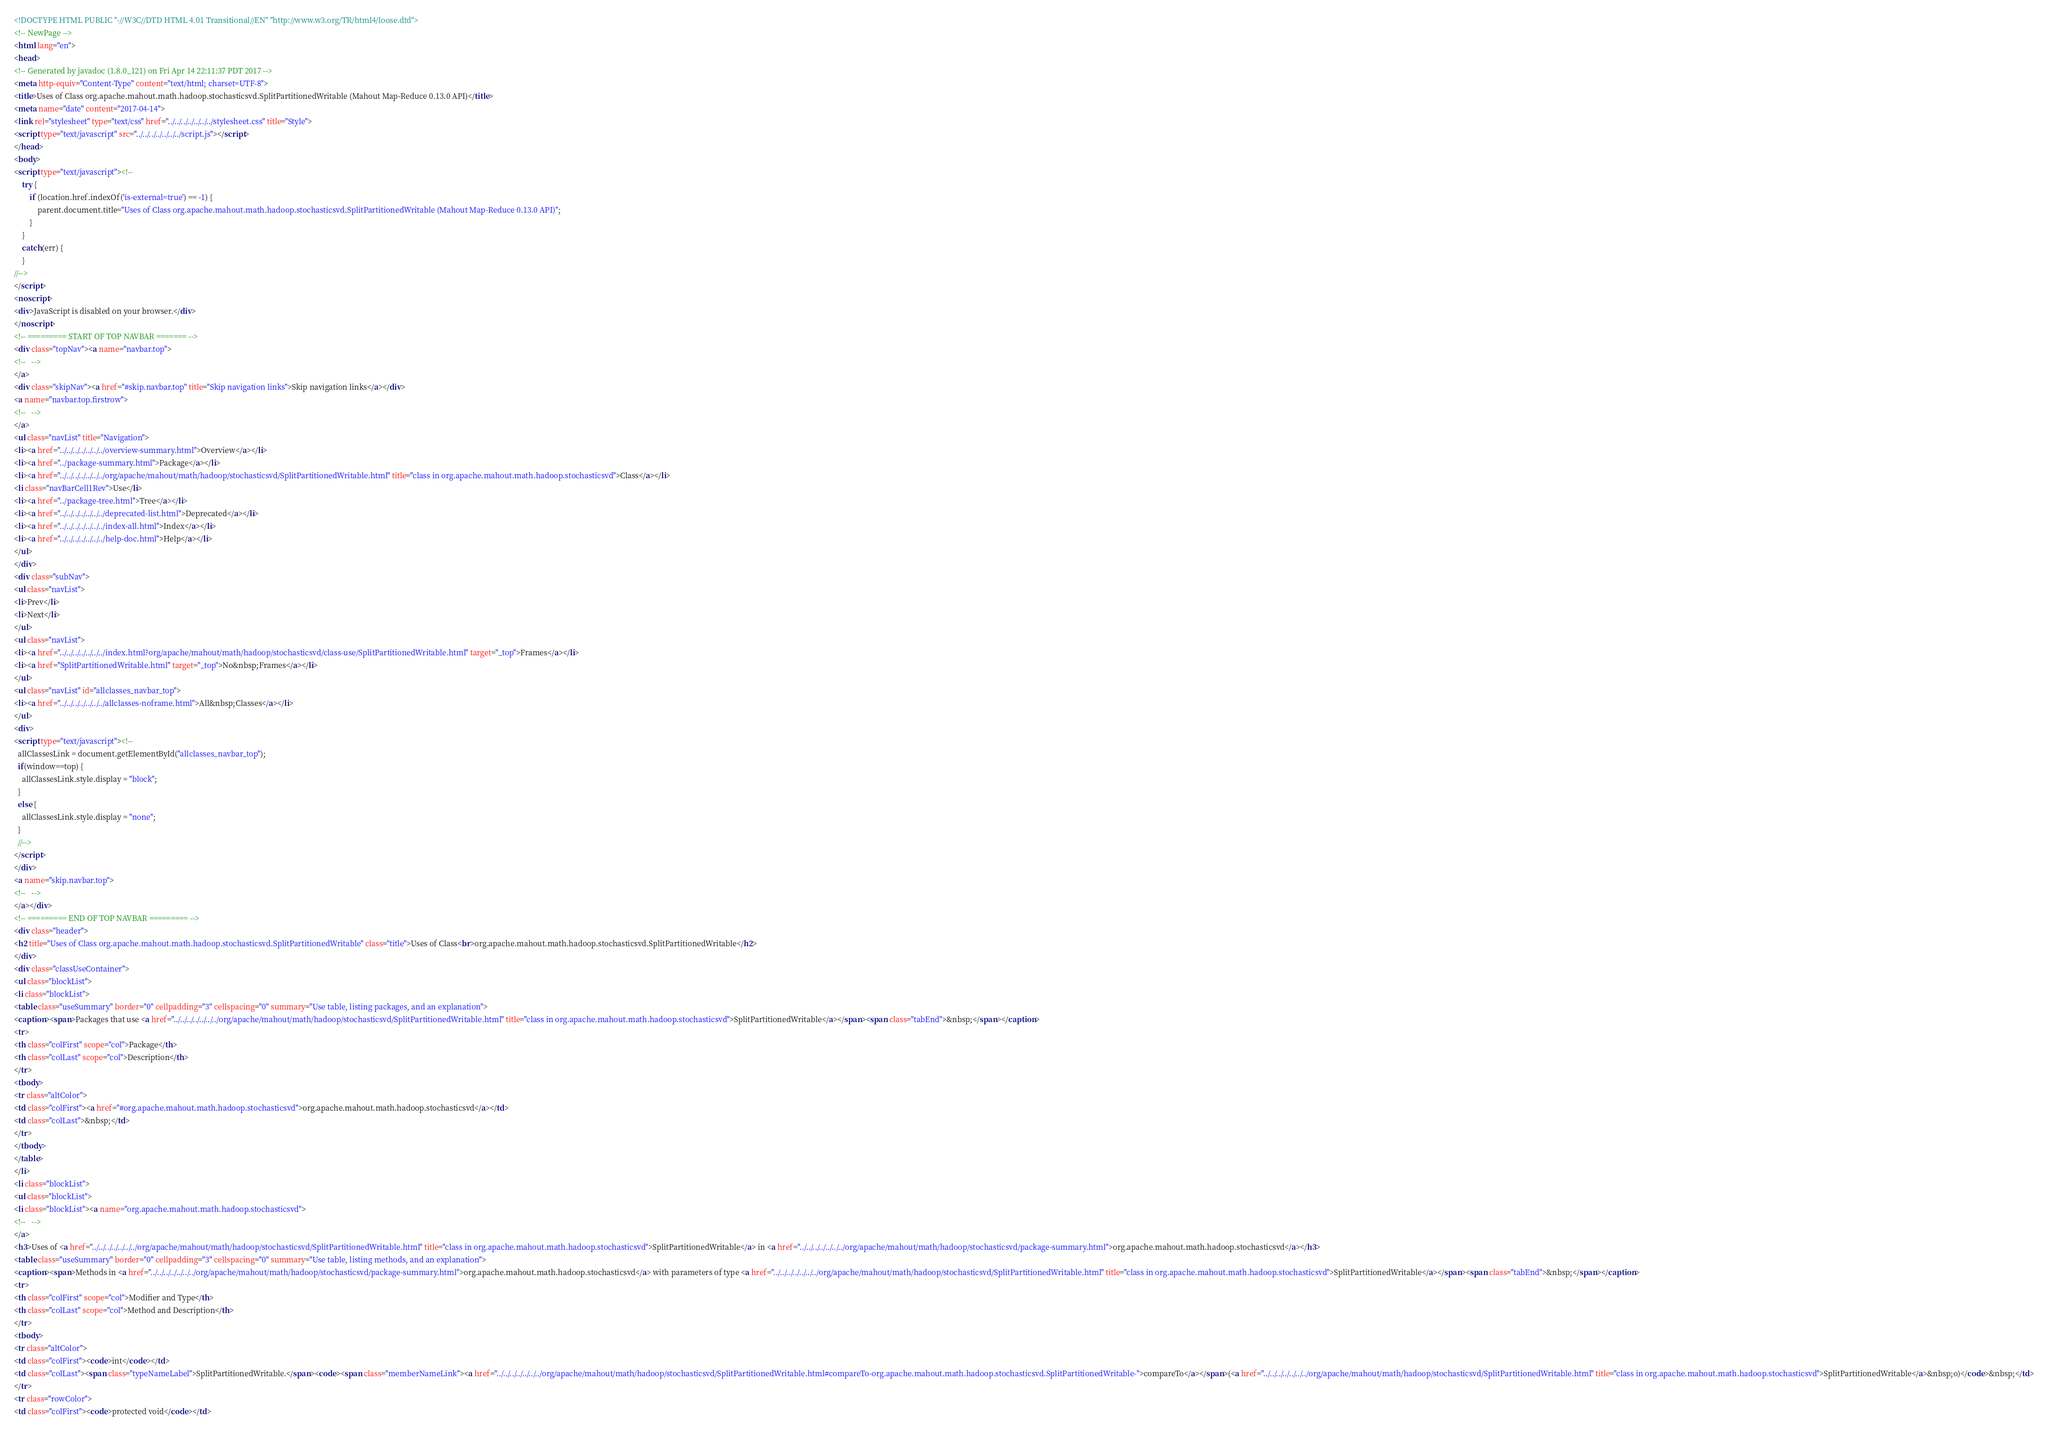<code> <loc_0><loc_0><loc_500><loc_500><_HTML_><!DOCTYPE HTML PUBLIC "-//W3C//DTD HTML 4.01 Transitional//EN" "http://www.w3.org/TR/html4/loose.dtd">
<!-- NewPage -->
<html lang="en">
<head>
<!-- Generated by javadoc (1.8.0_121) on Fri Apr 14 22:11:37 PDT 2017 -->
<meta http-equiv="Content-Type" content="text/html; charset=UTF-8">
<title>Uses of Class org.apache.mahout.math.hadoop.stochasticsvd.SplitPartitionedWritable (Mahout Map-Reduce 0.13.0 API)</title>
<meta name="date" content="2017-04-14">
<link rel="stylesheet" type="text/css" href="../../../../../../../stylesheet.css" title="Style">
<script type="text/javascript" src="../../../../../../../script.js"></script>
</head>
<body>
<script type="text/javascript"><!--
    try {
        if (location.href.indexOf('is-external=true') == -1) {
            parent.document.title="Uses of Class org.apache.mahout.math.hadoop.stochasticsvd.SplitPartitionedWritable (Mahout Map-Reduce 0.13.0 API)";
        }
    }
    catch(err) {
    }
//-->
</script>
<noscript>
<div>JavaScript is disabled on your browser.</div>
</noscript>
<!-- ========= START OF TOP NAVBAR ======= -->
<div class="topNav"><a name="navbar.top">
<!--   -->
</a>
<div class="skipNav"><a href="#skip.navbar.top" title="Skip navigation links">Skip navigation links</a></div>
<a name="navbar.top.firstrow">
<!--   -->
</a>
<ul class="navList" title="Navigation">
<li><a href="../../../../../../../overview-summary.html">Overview</a></li>
<li><a href="../package-summary.html">Package</a></li>
<li><a href="../../../../../../../org/apache/mahout/math/hadoop/stochasticsvd/SplitPartitionedWritable.html" title="class in org.apache.mahout.math.hadoop.stochasticsvd">Class</a></li>
<li class="navBarCell1Rev">Use</li>
<li><a href="../package-tree.html">Tree</a></li>
<li><a href="../../../../../../../deprecated-list.html">Deprecated</a></li>
<li><a href="../../../../../../../index-all.html">Index</a></li>
<li><a href="../../../../../../../help-doc.html">Help</a></li>
</ul>
</div>
<div class="subNav">
<ul class="navList">
<li>Prev</li>
<li>Next</li>
</ul>
<ul class="navList">
<li><a href="../../../../../../../index.html?org/apache/mahout/math/hadoop/stochasticsvd/class-use/SplitPartitionedWritable.html" target="_top">Frames</a></li>
<li><a href="SplitPartitionedWritable.html" target="_top">No&nbsp;Frames</a></li>
</ul>
<ul class="navList" id="allclasses_navbar_top">
<li><a href="../../../../../../../allclasses-noframe.html">All&nbsp;Classes</a></li>
</ul>
<div>
<script type="text/javascript"><!--
  allClassesLink = document.getElementById("allclasses_navbar_top");
  if(window==top) {
    allClassesLink.style.display = "block";
  }
  else {
    allClassesLink.style.display = "none";
  }
  //-->
</script>
</div>
<a name="skip.navbar.top">
<!--   -->
</a></div>
<!-- ========= END OF TOP NAVBAR ========= -->
<div class="header">
<h2 title="Uses of Class org.apache.mahout.math.hadoop.stochasticsvd.SplitPartitionedWritable" class="title">Uses of Class<br>org.apache.mahout.math.hadoop.stochasticsvd.SplitPartitionedWritable</h2>
</div>
<div class="classUseContainer">
<ul class="blockList">
<li class="blockList">
<table class="useSummary" border="0" cellpadding="3" cellspacing="0" summary="Use table, listing packages, and an explanation">
<caption><span>Packages that use <a href="../../../../../../../org/apache/mahout/math/hadoop/stochasticsvd/SplitPartitionedWritable.html" title="class in org.apache.mahout.math.hadoop.stochasticsvd">SplitPartitionedWritable</a></span><span class="tabEnd">&nbsp;</span></caption>
<tr>
<th class="colFirst" scope="col">Package</th>
<th class="colLast" scope="col">Description</th>
</tr>
<tbody>
<tr class="altColor">
<td class="colFirst"><a href="#org.apache.mahout.math.hadoop.stochasticsvd">org.apache.mahout.math.hadoop.stochasticsvd</a></td>
<td class="colLast">&nbsp;</td>
</tr>
</tbody>
</table>
</li>
<li class="blockList">
<ul class="blockList">
<li class="blockList"><a name="org.apache.mahout.math.hadoop.stochasticsvd">
<!--   -->
</a>
<h3>Uses of <a href="../../../../../../../org/apache/mahout/math/hadoop/stochasticsvd/SplitPartitionedWritable.html" title="class in org.apache.mahout.math.hadoop.stochasticsvd">SplitPartitionedWritable</a> in <a href="../../../../../../../org/apache/mahout/math/hadoop/stochasticsvd/package-summary.html">org.apache.mahout.math.hadoop.stochasticsvd</a></h3>
<table class="useSummary" border="0" cellpadding="3" cellspacing="0" summary="Use table, listing methods, and an explanation">
<caption><span>Methods in <a href="../../../../../../../org/apache/mahout/math/hadoop/stochasticsvd/package-summary.html">org.apache.mahout.math.hadoop.stochasticsvd</a> with parameters of type <a href="../../../../../../../org/apache/mahout/math/hadoop/stochasticsvd/SplitPartitionedWritable.html" title="class in org.apache.mahout.math.hadoop.stochasticsvd">SplitPartitionedWritable</a></span><span class="tabEnd">&nbsp;</span></caption>
<tr>
<th class="colFirst" scope="col">Modifier and Type</th>
<th class="colLast" scope="col">Method and Description</th>
</tr>
<tbody>
<tr class="altColor">
<td class="colFirst"><code>int</code></td>
<td class="colLast"><span class="typeNameLabel">SplitPartitionedWritable.</span><code><span class="memberNameLink"><a href="../../../../../../../org/apache/mahout/math/hadoop/stochasticsvd/SplitPartitionedWritable.html#compareTo-org.apache.mahout.math.hadoop.stochasticsvd.SplitPartitionedWritable-">compareTo</a></span>(<a href="../../../../../../../org/apache/mahout/math/hadoop/stochasticsvd/SplitPartitionedWritable.html" title="class in org.apache.mahout.math.hadoop.stochasticsvd">SplitPartitionedWritable</a>&nbsp;o)</code>&nbsp;</td>
</tr>
<tr class="rowColor">
<td class="colFirst"><code>protected void</code></td></code> 